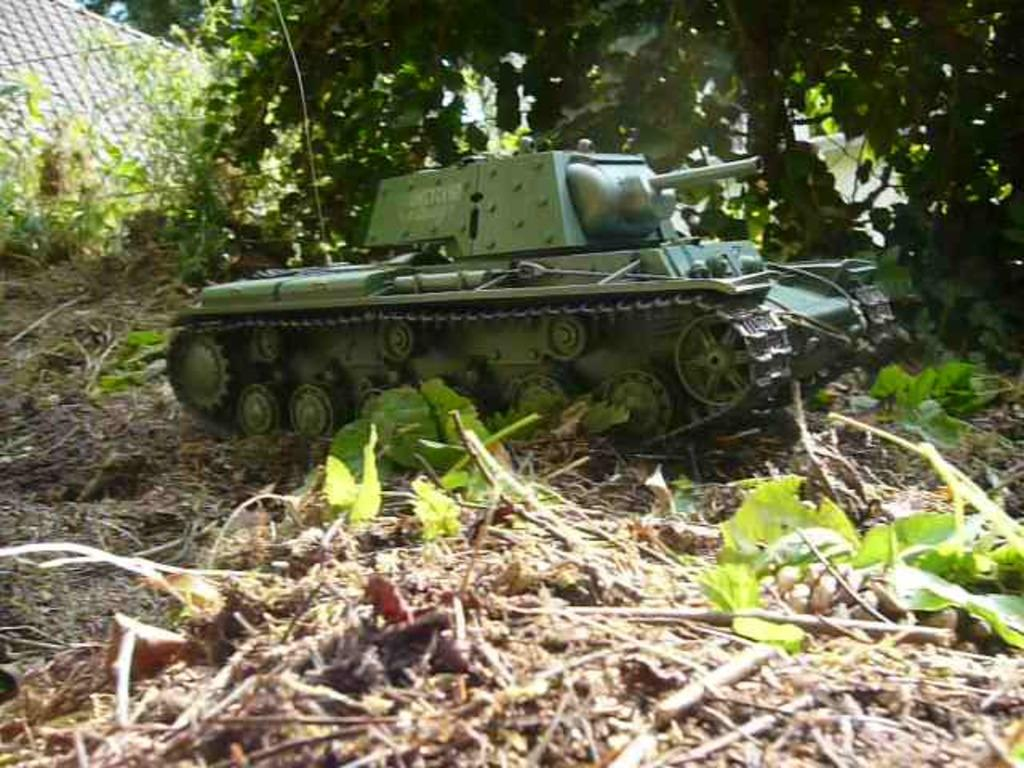What is the main subject in the center of the image? There is a battle tank in the center of the image. How is the battle tank positioned in the image? The battle tank is on the ground. What can be seen at the bottom of the image? There are plants and leaves at the bottom of the image. What is visible in the background of the image? There is a building, trees, and plants in the background of the image. What type of stocking is hanging from the battle tank in the image? There is no stocking hanging from the battle tank in the image. What is the condition of the boats in the background of the image? There are no boats present in the image. 